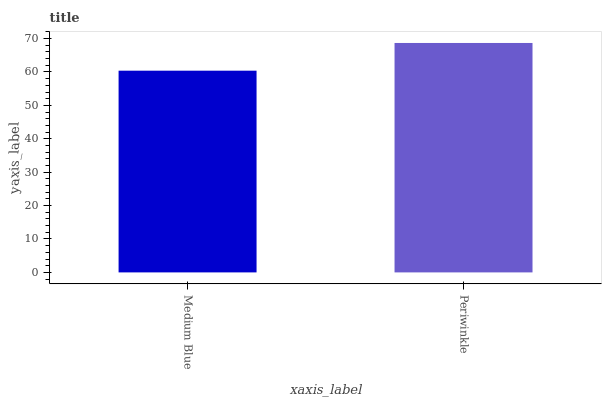Is Medium Blue the minimum?
Answer yes or no. Yes. Is Periwinkle the maximum?
Answer yes or no. Yes. Is Periwinkle the minimum?
Answer yes or no. No. Is Periwinkle greater than Medium Blue?
Answer yes or no. Yes. Is Medium Blue less than Periwinkle?
Answer yes or no. Yes. Is Medium Blue greater than Periwinkle?
Answer yes or no. No. Is Periwinkle less than Medium Blue?
Answer yes or no. No. Is Periwinkle the high median?
Answer yes or no. Yes. Is Medium Blue the low median?
Answer yes or no. Yes. Is Medium Blue the high median?
Answer yes or no. No. Is Periwinkle the low median?
Answer yes or no. No. 